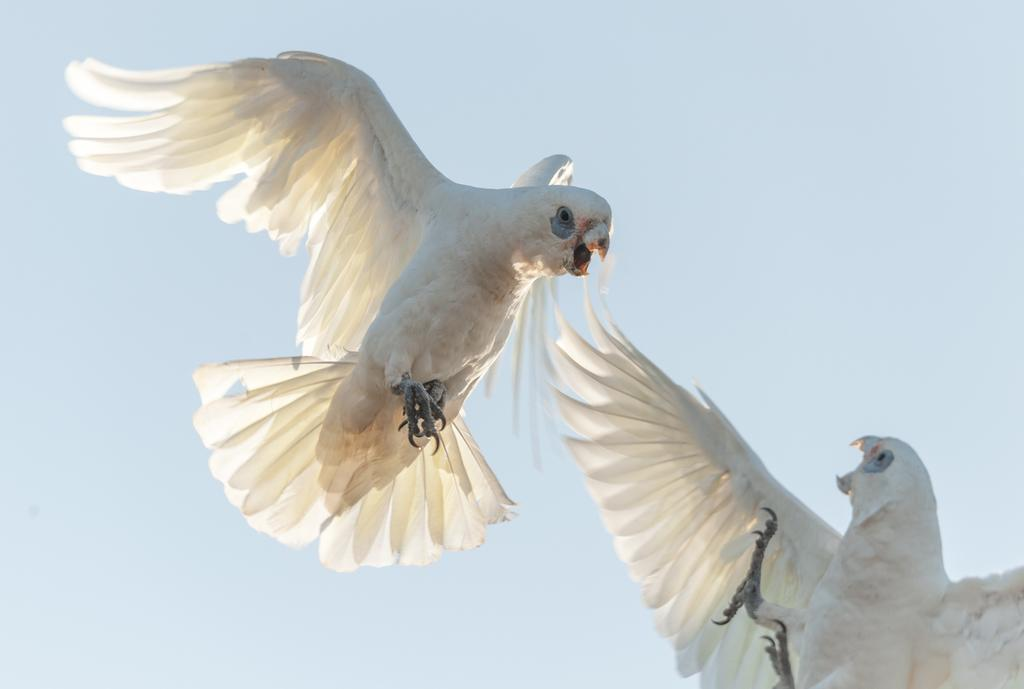What type of animals can be seen in the image? Birds can be seen in the image. What are the birds doing in the image? The birds are flying in the sky. How many houses can be seen in the image? There are no houses present in the image; it features birds flying in the sky. What type of dress is the bird wearing in the image? Birds do not wear dresses, and there are no birds wearing dresses in the image. 